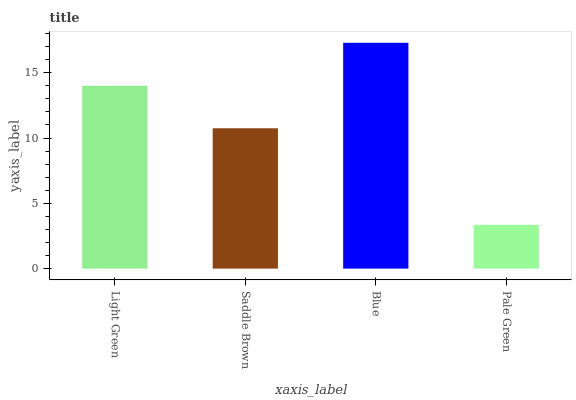Is Pale Green the minimum?
Answer yes or no. Yes. Is Blue the maximum?
Answer yes or no. Yes. Is Saddle Brown the minimum?
Answer yes or no. No. Is Saddle Brown the maximum?
Answer yes or no. No. Is Light Green greater than Saddle Brown?
Answer yes or no. Yes. Is Saddle Brown less than Light Green?
Answer yes or no. Yes. Is Saddle Brown greater than Light Green?
Answer yes or no. No. Is Light Green less than Saddle Brown?
Answer yes or no. No. Is Light Green the high median?
Answer yes or no. Yes. Is Saddle Brown the low median?
Answer yes or no. Yes. Is Saddle Brown the high median?
Answer yes or no. No. Is Light Green the low median?
Answer yes or no. No. 